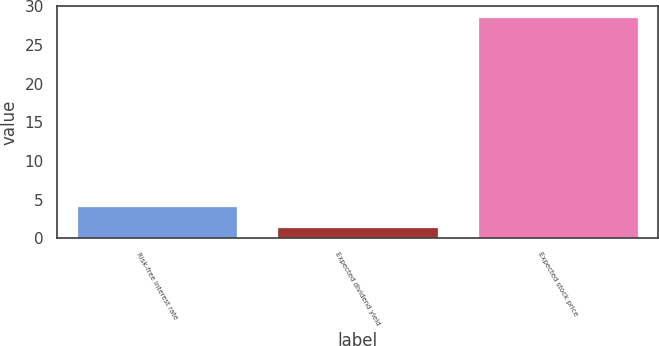<chart> <loc_0><loc_0><loc_500><loc_500><bar_chart><fcel>Risk-free interest rate<fcel>Expected dividend yield<fcel>Expected stock price<nl><fcel>4.12<fcel>1.4<fcel>28.6<nl></chart> 